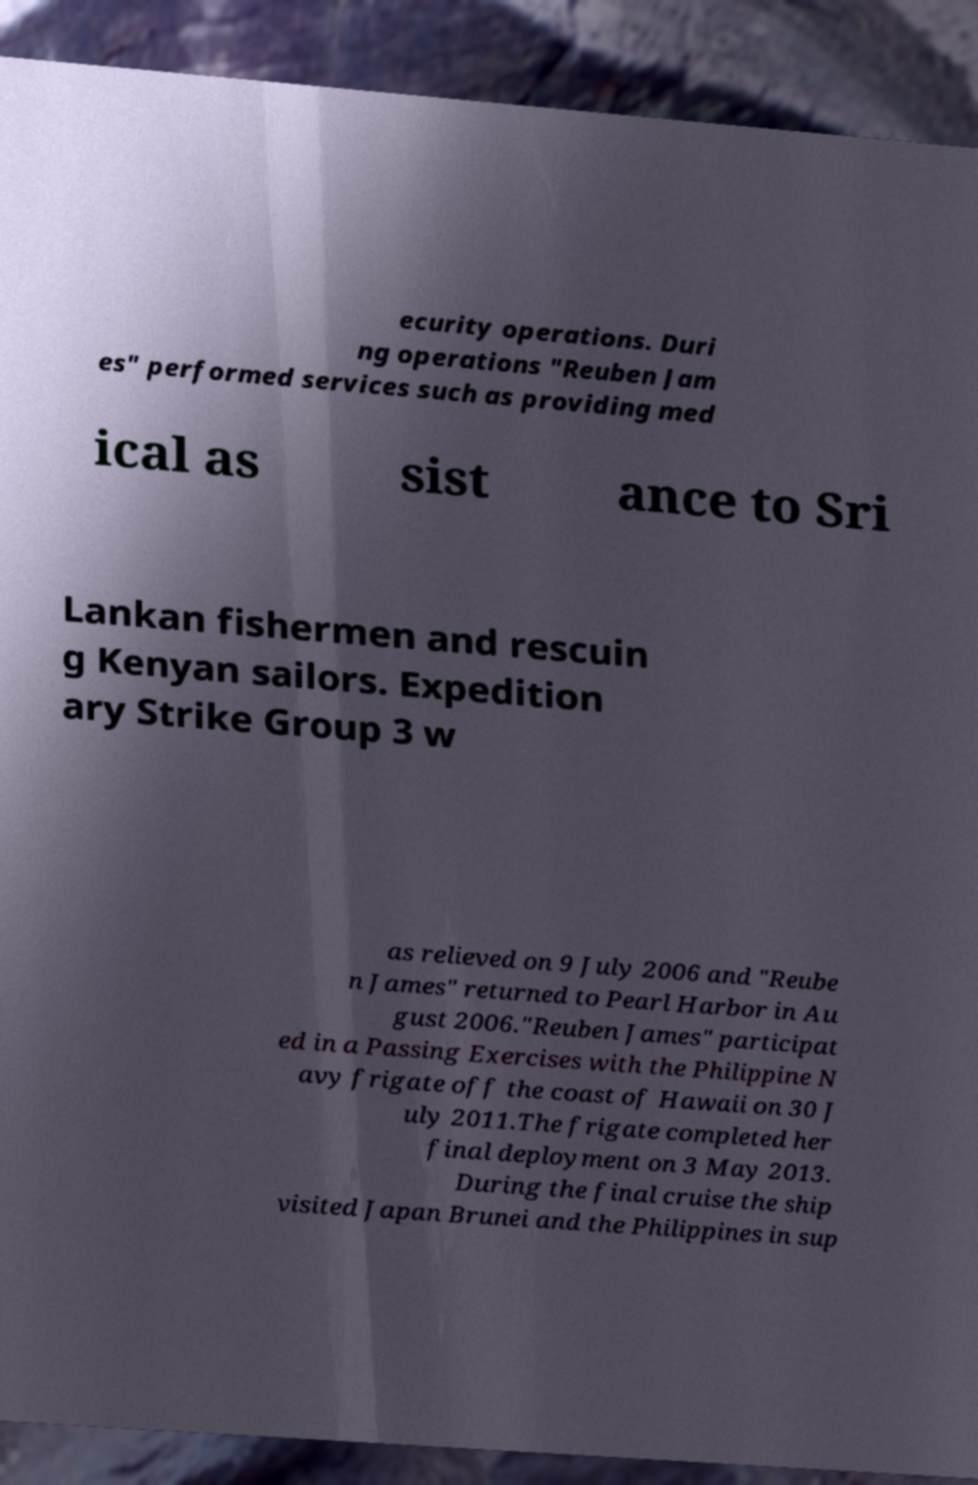Could you assist in decoding the text presented in this image and type it out clearly? ecurity operations. Duri ng operations "Reuben Jam es" performed services such as providing med ical as sist ance to Sri Lankan fishermen and rescuin g Kenyan sailors. Expedition ary Strike Group 3 w as relieved on 9 July 2006 and "Reube n James" returned to Pearl Harbor in Au gust 2006."Reuben James" participat ed in a Passing Exercises with the Philippine N avy frigate off the coast of Hawaii on 30 J uly 2011.The frigate completed her final deployment on 3 May 2013. During the final cruise the ship visited Japan Brunei and the Philippines in sup 